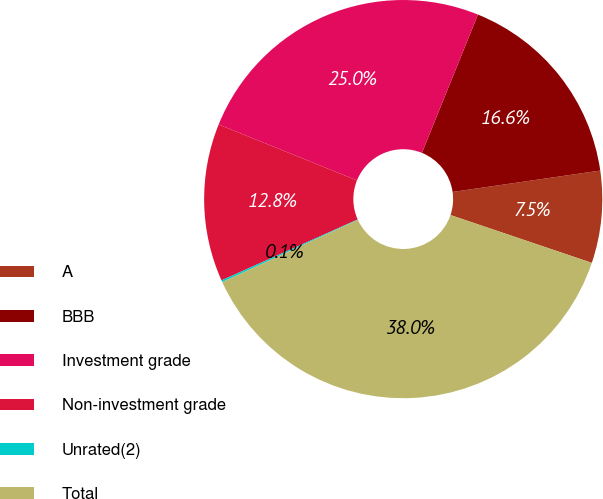Convert chart to OTSL. <chart><loc_0><loc_0><loc_500><loc_500><pie_chart><fcel>A<fcel>BBB<fcel>Investment grade<fcel>Non-investment grade<fcel>Unrated(2)<fcel>Total<nl><fcel>7.48%<fcel>16.59%<fcel>25.01%<fcel>12.81%<fcel>0.15%<fcel>37.97%<nl></chart> 